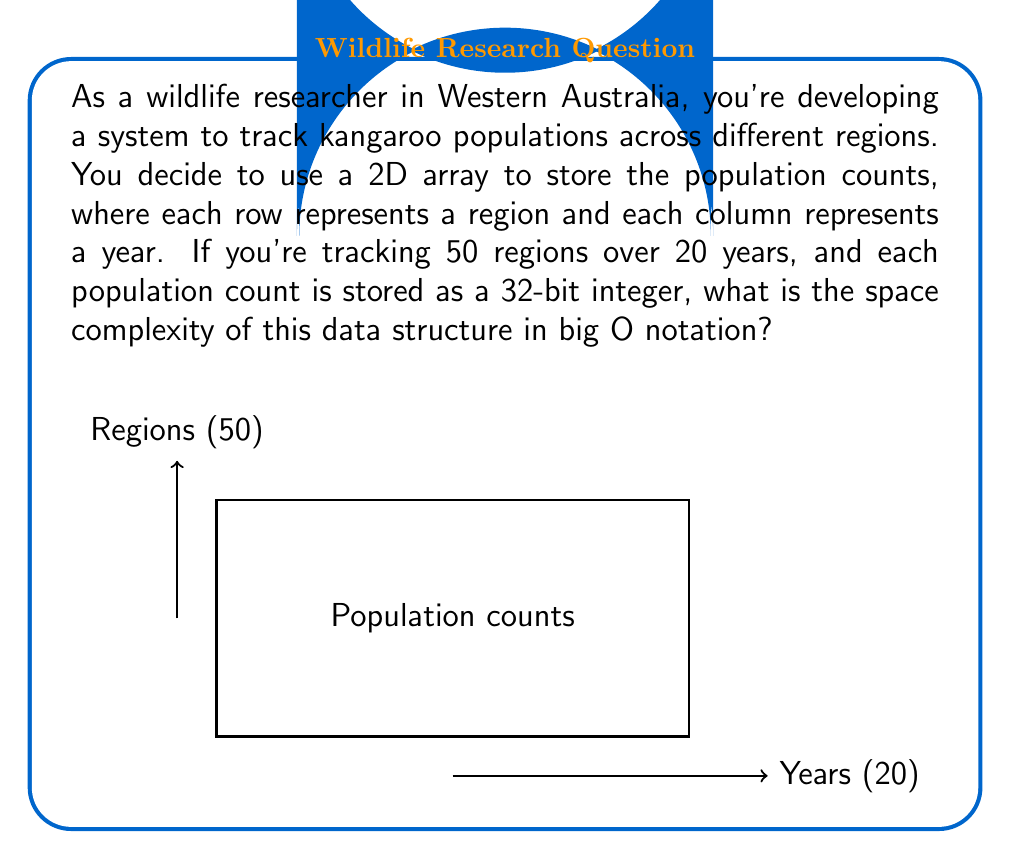Teach me how to tackle this problem. Let's break this down step-by-step:

1) We're using a 2D array to store the data. The dimensions are:
   - 50 rows (regions)
   - 20 columns (years)

2) Each element in the array is a 32-bit integer, which is a constant size regardless of the value stored.

3) The total number of elements in the array is:
   $$ 50 \times 20 = 1000 $$

4) The space required for each element is constant (32 bits or 4 bytes), so the total space is proportional to the number of elements.

5) In big O notation, we express this as $O(mn)$, where:
   - $m$ is the number of rows (regions)
   - $n$ is the number of columns (years)

6) The actual space used is $4mn$ bytes, but in big O notation, we drop constants.

7) The space complexity doesn't depend on the values stored, only on the dimensions of the array.

Therefore, the space complexity is $O(mn)$ or, in this specific case, $O(50 \times 20)$, which simplifies to $O(1000)$. However, in big O notation, we express this in terms of variables rather than specific values.
Answer: $O(mn)$ 